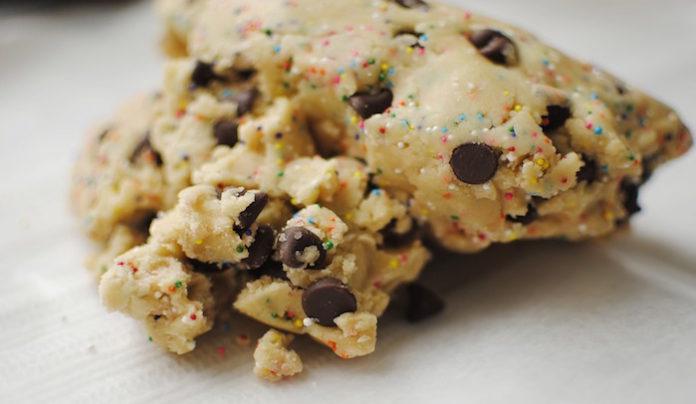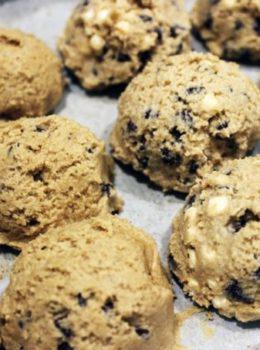The first image is the image on the left, the second image is the image on the right. For the images displayed, is the sentence "A utensil with a handle is touching raw chocolate chip cookie dough in at least one image." factually correct? Answer yes or no. No. The first image is the image on the left, the second image is the image on the right. Assess this claim about the two images: "Some of the cookie dough is in balls neatly lined up.". Correct or not? Answer yes or no. Yes. 